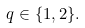Convert formula to latex. <formula><loc_0><loc_0><loc_500><loc_500>q \in \{ 1 , 2 \} .</formula> 